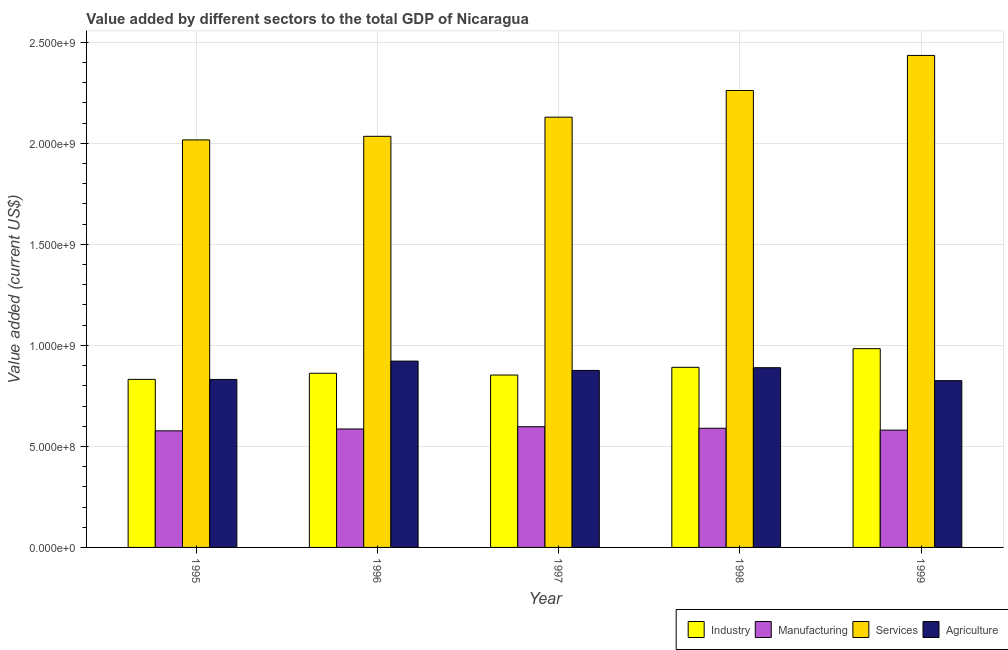Are the number of bars per tick equal to the number of legend labels?
Your answer should be compact. Yes. Are the number of bars on each tick of the X-axis equal?
Your response must be concise. Yes. How many bars are there on the 2nd tick from the left?
Provide a succinct answer. 4. How many bars are there on the 5th tick from the right?
Ensure brevity in your answer.  4. In how many cases, is the number of bars for a given year not equal to the number of legend labels?
Ensure brevity in your answer.  0. What is the value added by industrial sector in 1996?
Provide a short and direct response. 8.62e+08. Across all years, what is the maximum value added by agricultural sector?
Provide a short and direct response. 9.22e+08. Across all years, what is the minimum value added by manufacturing sector?
Provide a short and direct response. 5.77e+08. In which year was the value added by industrial sector maximum?
Offer a very short reply. 1999. In which year was the value added by agricultural sector minimum?
Keep it short and to the point. 1999. What is the total value added by agricultural sector in the graph?
Ensure brevity in your answer.  4.34e+09. What is the difference between the value added by agricultural sector in 1995 and that in 1996?
Provide a succinct answer. -9.08e+07. What is the difference between the value added by industrial sector in 1995 and the value added by manufacturing sector in 1999?
Give a very brief answer. -1.52e+08. What is the average value added by manufacturing sector per year?
Your answer should be very brief. 5.86e+08. In the year 1999, what is the difference between the value added by services sector and value added by agricultural sector?
Offer a very short reply. 0. What is the ratio of the value added by manufacturing sector in 1996 to that in 1998?
Give a very brief answer. 0.99. Is the value added by manufacturing sector in 1997 less than that in 1998?
Keep it short and to the point. No. Is the difference between the value added by services sector in 1995 and 1997 greater than the difference between the value added by manufacturing sector in 1995 and 1997?
Offer a very short reply. No. What is the difference between the highest and the second highest value added by agricultural sector?
Offer a very short reply. 3.27e+07. What is the difference between the highest and the lowest value added by agricultural sector?
Offer a terse response. 9.67e+07. In how many years, is the value added by industrial sector greater than the average value added by industrial sector taken over all years?
Provide a short and direct response. 2. Is the sum of the value added by industrial sector in 1996 and 1998 greater than the maximum value added by agricultural sector across all years?
Your answer should be compact. Yes. Is it the case that in every year, the sum of the value added by industrial sector and value added by agricultural sector is greater than the sum of value added by manufacturing sector and value added by services sector?
Your response must be concise. No. What does the 1st bar from the left in 1998 represents?
Offer a very short reply. Industry. What does the 1st bar from the right in 1996 represents?
Offer a very short reply. Agriculture. Is it the case that in every year, the sum of the value added by industrial sector and value added by manufacturing sector is greater than the value added by services sector?
Offer a terse response. No. How many years are there in the graph?
Provide a succinct answer. 5. Does the graph contain any zero values?
Keep it short and to the point. No. Does the graph contain grids?
Make the answer very short. Yes. Where does the legend appear in the graph?
Provide a succinct answer. Bottom right. How many legend labels are there?
Your answer should be very brief. 4. What is the title of the graph?
Offer a terse response. Value added by different sectors to the total GDP of Nicaragua. What is the label or title of the Y-axis?
Keep it short and to the point. Value added (current US$). What is the Value added (current US$) in Industry in 1995?
Give a very brief answer. 8.32e+08. What is the Value added (current US$) of Manufacturing in 1995?
Your answer should be compact. 5.77e+08. What is the Value added (current US$) in Services in 1995?
Provide a succinct answer. 2.02e+09. What is the Value added (current US$) of Agriculture in 1995?
Give a very brief answer. 8.31e+08. What is the Value added (current US$) of Industry in 1996?
Provide a succinct answer. 8.62e+08. What is the Value added (current US$) in Manufacturing in 1996?
Give a very brief answer. 5.86e+08. What is the Value added (current US$) in Services in 1996?
Offer a terse response. 2.03e+09. What is the Value added (current US$) in Agriculture in 1996?
Your answer should be compact. 9.22e+08. What is the Value added (current US$) of Industry in 1997?
Ensure brevity in your answer.  8.53e+08. What is the Value added (current US$) of Manufacturing in 1997?
Ensure brevity in your answer.  5.98e+08. What is the Value added (current US$) in Services in 1997?
Offer a terse response. 2.13e+09. What is the Value added (current US$) in Agriculture in 1997?
Provide a succinct answer. 8.76e+08. What is the Value added (current US$) of Industry in 1998?
Provide a succinct answer. 8.91e+08. What is the Value added (current US$) in Manufacturing in 1998?
Your answer should be compact. 5.90e+08. What is the Value added (current US$) in Services in 1998?
Your answer should be compact. 2.26e+09. What is the Value added (current US$) in Agriculture in 1998?
Provide a succinct answer. 8.90e+08. What is the Value added (current US$) of Industry in 1999?
Offer a very short reply. 9.84e+08. What is the Value added (current US$) in Manufacturing in 1999?
Your response must be concise. 5.81e+08. What is the Value added (current US$) in Services in 1999?
Make the answer very short. 2.44e+09. What is the Value added (current US$) in Agriculture in 1999?
Your answer should be compact. 8.25e+08. Across all years, what is the maximum Value added (current US$) in Industry?
Keep it short and to the point. 9.84e+08. Across all years, what is the maximum Value added (current US$) of Manufacturing?
Provide a short and direct response. 5.98e+08. Across all years, what is the maximum Value added (current US$) in Services?
Provide a succinct answer. 2.44e+09. Across all years, what is the maximum Value added (current US$) in Agriculture?
Ensure brevity in your answer.  9.22e+08. Across all years, what is the minimum Value added (current US$) in Industry?
Ensure brevity in your answer.  8.32e+08. Across all years, what is the minimum Value added (current US$) in Manufacturing?
Your answer should be compact. 5.77e+08. Across all years, what is the minimum Value added (current US$) in Services?
Make the answer very short. 2.02e+09. Across all years, what is the minimum Value added (current US$) of Agriculture?
Offer a very short reply. 8.25e+08. What is the total Value added (current US$) in Industry in the graph?
Provide a short and direct response. 4.42e+09. What is the total Value added (current US$) of Manufacturing in the graph?
Offer a terse response. 2.93e+09. What is the total Value added (current US$) of Services in the graph?
Offer a very short reply. 1.09e+1. What is the total Value added (current US$) in Agriculture in the graph?
Offer a very short reply. 4.34e+09. What is the difference between the Value added (current US$) of Industry in 1995 and that in 1996?
Keep it short and to the point. -3.02e+07. What is the difference between the Value added (current US$) of Manufacturing in 1995 and that in 1996?
Offer a terse response. -9.22e+06. What is the difference between the Value added (current US$) of Services in 1995 and that in 1996?
Provide a succinct answer. -1.77e+07. What is the difference between the Value added (current US$) of Agriculture in 1995 and that in 1996?
Give a very brief answer. -9.08e+07. What is the difference between the Value added (current US$) in Industry in 1995 and that in 1997?
Provide a short and direct response. -2.14e+07. What is the difference between the Value added (current US$) of Manufacturing in 1995 and that in 1997?
Give a very brief answer. -2.05e+07. What is the difference between the Value added (current US$) of Services in 1995 and that in 1997?
Offer a very short reply. -1.13e+08. What is the difference between the Value added (current US$) of Agriculture in 1995 and that in 1997?
Offer a terse response. -4.47e+07. What is the difference between the Value added (current US$) of Industry in 1995 and that in 1998?
Provide a short and direct response. -5.96e+07. What is the difference between the Value added (current US$) of Manufacturing in 1995 and that in 1998?
Offer a terse response. -1.28e+07. What is the difference between the Value added (current US$) in Services in 1995 and that in 1998?
Ensure brevity in your answer.  -2.45e+08. What is the difference between the Value added (current US$) in Agriculture in 1995 and that in 1998?
Your answer should be compact. -5.81e+07. What is the difference between the Value added (current US$) of Industry in 1995 and that in 1999?
Make the answer very short. -1.52e+08. What is the difference between the Value added (current US$) of Manufacturing in 1995 and that in 1999?
Ensure brevity in your answer.  -3.50e+06. What is the difference between the Value added (current US$) of Services in 1995 and that in 1999?
Ensure brevity in your answer.  -4.18e+08. What is the difference between the Value added (current US$) in Agriculture in 1995 and that in 1999?
Your response must be concise. 5.94e+06. What is the difference between the Value added (current US$) of Industry in 1996 and that in 1997?
Keep it short and to the point. 8.83e+06. What is the difference between the Value added (current US$) in Manufacturing in 1996 and that in 1997?
Ensure brevity in your answer.  -1.13e+07. What is the difference between the Value added (current US$) of Services in 1996 and that in 1997?
Keep it short and to the point. -9.48e+07. What is the difference between the Value added (current US$) in Agriculture in 1996 and that in 1997?
Provide a short and direct response. 4.61e+07. What is the difference between the Value added (current US$) in Industry in 1996 and that in 1998?
Provide a succinct answer. -2.94e+07. What is the difference between the Value added (current US$) in Manufacturing in 1996 and that in 1998?
Your answer should be compact. -3.60e+06. What is the difference between the Value added (current US$) in Services in 1996 and that in 1998?
Make the answer very short. -2.27e+08. What is the difference between the Value added (current US$) in Agriculture in 1996 and that in 1998?
Your answer should be very brief. 3.27e+07. What is the difference between the Value added (current US$) in Industry in 1996 and that in 1999?
Your answer should be very brief. -1.22e+08. What is the difference between the Value added (current US$) in Manufacturing in 1996 and that in 1999?
Offer a very short reply. 5.72e+06. What is the difference between the Value added (current US$) of Services in 1996 and that in 1999?
Offer a very short reply. -4.00e+08. What is the difference between the Value added (current US$) in Agriculture in 1996 and that in 1999?
Offer a terse response. 9.67e+07. What is the difference between the Value added (current US$) of Industry in 1997 and that in 1998?
Offer a very short reply. -3.82e+07. What is the difference between the Value added (current US$) in Manufacturing in 1997 and that in 1998?
Your answer should be compact. 7.65e+06. What is the difference between the Value added (current US$) of Services in 1997 and that in 1998?
Provide a succinct answer. -1.32e+08. What is the difference between the Value added (current US$) in Agriculture in 1997 and that in 1998?
Your answer should be very brief. -1.35e+07. What is the difference between the Value added (current US$) in Industry in 1997 and that in 1999?
Provide a succinct answer. -1.31e+08. What is the difference between the Value added (current US$) of Manufacturing in 1997 and that in 1999?
Keep it short and to the point. 1.70e+07. What is the difference between the Value added (current US$) in Services in 1997 and that in 1999?
Offer a terse response. -3.06e+08. What is the difference between the Value added (current US$) of Agriculture in 1997 and that in 1999?
Provide a succinct answer. 5.06e+07. What is the difference between the Value added (current US$) of Industry in 1998 and that in 1999?
Offer a terse response. -9.23e+07. What is the difference between the Value added (current US$) of Manufacturing in 1998 and that in 1999?
Offer a terse response. 9.32e+06. What is the difference between the Value added (current US$) of Services in 1998 and that in 1999?
Offer a terse response. -1.74e+08. What is the difference between the Value added (current US$) of Agriculture in 1998 and that in 1999?
Your response must be concise. 6.41e+07. What is the difference between the Value added (current US$) in Industry in 1995 and the Value added (current US$) in Manufacturing in 1996?
Your answer should be compact. 2.46e+08. What is the difference between the Value added (current US$) of Industry in 1995 and the Value added (current US$) of Services in 1996?
Ensure brevity in your answer.  -1.20e+09. What is the difference between the Value added (current US$) in Industry in 1995 and the Value added (current US$) in Agriculture in 1996?
Provide a short and direct response. -9.04e+07. What is the difference between the Value added (current US$) in Manufacturing in 1995 and the Value added (current US$) in Services in 1996?
Your answer should be compact. -1.46e+09. What is the difference between the Value added (current US$) of Manufacturing in 1995 and the Value added (current US$) of Agriculture in 1996?
Your answer should be very brief. -3.45e+08. What is the difference between the Value added (current US$) in Services in 1995 and the Value added (current US$) in Agriculture in 1996?
Give a very brief answer. 1.09e+09. What is the difference between the Value added (current US$) in Industry in 1995 and the Value added (current US$) in Manufacturing in 1997?
Provide a succinct answer. 2.34e+08. What is the difference between the Value added (current US$) of Industry in 1995 and the Value added (current US$) of Services in 1997?
Your answer should be compact. -1.30e+09. What is the difference between the Value added (current US$) of Industry in 1995 and the Value added (current US$) of Agriculture in 1997?
Provide a succinct answer. -4.43e+07. What is the difference between the Value added (current US$) in Manufacturing in 1995 and the Value added (current US$) in Services in 1997?
Your response must be concise. -1.55e+09. What is the difference between the Value added (current US$) in Manufacturing in 1995 and the Value added (current US$) in Agriculture in 1997?
Keep it short and to the point. -2.99e+08. What is the difference between the Value added (current US$) in Services in 1995 and the Value added (current US$) in Agriculture in 1997?
Your answer should be compact. 1.14e+09. What is the difference between the Value added (current US$) of Industry in 1995 and the Value added (current US$) of Manufacturing in 1998?
Your answer should be very brief. 2.42e+08. What is the difference between the Value added (current US$) of Industry in 1995 and the Value added (current US$) of Services in 1998?
Your answer should be compact. -1.43e+09. What is the difference between the Value added (current US$) of Industry in 1995 and the Value added (current US$) of Agriculture in 1998?
Provide a short and direct response. -5.77e+07. What is the difference between the Value added (current US$) of Manufacturing in 1995 and the Value added (current US$) of Services in 1998?
Give a very brief answer. -1.68e+09. What is the difference between the Value added (current US$) of Manufacturing in 1995 and the Value added (current US$) of Agriculture in 1998?
Provide a short and direct response. -3.12e+08. What is the difference between the Value added (current US$) in Services in 1995 and the Value added (current US$) in Agriculture in 1998?
Offer a very short reply. 1.13e+09. What is the difference between the Value added (current US$) in Industry in 1995 and the Value added (current US$) in Manufacturing in 1999?
Your response must be concise. 2.51e+08. What is the difference between the Value added (current US$) in Industry in 1995 and the Value added (current US$) in Services in 1999?
Provide a succinct answer. -1.60e+09. What is the difference between the Value added (current US$) in Industry in 1995 and the Value added (current US$) in Agriculture in 1999?
Offer a terse response. 6.36e+06. What is the difference between the Value added (current US$) of Manufacturing in 1995 and the Value added (current US$) of Services in 1999?
Ensure brevity in your answer.  -1.86e+09. What is the difference between the Value added (current US$) in Manufacturing in 1995 and the Value added (current US$) in Agriculture in 1999?
Your answer should be very brief. -2.48e+08. What is the difference between the Value added (current US$) in Services in 1995 and the Value added (current US$) in Agriculture in 1999?
Provide a short and direct response. 1.19e+09. What is the difference between the Value added (current US$) in Industry in 1996 and the Value added (current US$) in Manufacturing in 1997?
Provide a succinct answer. 2.65e+08. What is the difference between the Value added (current US$) in Industry in 1996 and the Value added (current US$) in Services in 1997?
Offer a terse response. -1.27e+09. What is the difference between the Value added (current US$) of Industry in 1996 and the Value added (current US$) of Agriculture in 1997?
Keep it short and to the point. -1.40e+07. What is the difference between the Value added (current US$) of Manufacturing in 1996 and the Value added (current US$) of Services in 1997?
Offer a terse response. -1.54e+09. What is the difference between the Value added (current US$) in Manufacturing in 1996 and the Value added (current US$) in Agriculture in 1997?
Ensure brevity in your answer.  -2.90e+08. What is the difference between the Value added (current US$) of Services in 1996 and the Value added (current US$) of Agriculture in 1997?
Offer a terse response. 1.16e+09. What is the difference between the Value added (current US$) of Industry in 1996 and the Value added (current US$) of Manufacturing in 1998?
Your answer should be very brief. 2.72e+08. What is the difference between the Value added (current US$) in Industry in 1996 and the Value added (current US$) in Services in 1998?
Make the answer very short. -1.40e+09. What is the difference between the Value added (current US$) of Industry in 1996 and the Value added (current US$) of Agriculture in 1998?
Provide a short and direct response. -2.75e+07. What is the difference between the Value added (current US$) of Manufacturing in 1996 and the Value added (current US$) of Services in 1998?
Your response must be concise. -1.68e+09. What is the difference between the Value added (current US$) in Manufacturing in 1996 and the Value added (current US$) in Agriculture in 1998?
Offer a very short reply. -3.03e+08. What is the difference between the Value added (current US$) in Services in 1996 and the Value added (current US$) in Agriculture in 1998?
Provide a short and direct response. 1.15e+09. What is the difference between the Value added (current US$) in Industry in 1996 and the Value added (current US$) in Manufacturing in 1999?
Give a very brief answer. 2.82e+08. What is the difference between the Value added (current US$) in Industry in 1996 and the Value added (current US$) in Services in 1999?
Make the answer very short. -1.57e+09. What is the difference between the Value added (current US$) in Industry in 1996 and the Value added (current US$) in Agriculture in 1999?
Provide a succinct answer. 3.66e+07. What is the difference between the Value added (current US$) in Manufacturing in 1996 and the Value added (current US$) in Services in 1999?
Make the answer very short. -1.85e+09. What is the difference between the Value added (current US$) in Manufacturing in 1996 and the Value added (current US$) in Agriculture in 1999?
Your response must be concise. -2.39e+08. What is the difference between the Value added (current US$) of Services in 1996 and the Value added (current US$) of Agriculture in 1999?
Provide a short and direct response. 1.21e+09. What is the difference between the Value added (current US$) of Industry in 1997 and the Value added (current US$) of Manufacturing in 1998?
Offer a terse response. 2.63e+08. What is the difference between the Value added (current US$) of Industry in 1997 and the Value added (current US$) of Services in 1998?
Your response must be concise. -1.41e+09. What is the difference between the Value added (current US$) in Industry in 1997 and the Value added (current US$) in Agriculture in 1998?
Provide a short and direct response. -3.63e+07. What is the difference between the Value added (current US$) in Manufacturing in 1997 and the Value added (current US$) in Services in 1998?
Give a very brief answer. -1.66e+09. What is the difference between the Value added (current US$) of Manufacturing in 1997 and the Value added (current US$) of Agriculture in 1998?
Offer a terse response. -2.92e+08. What is the difference between the Value added (current US$) of Services in 1997 and the Value added (current US$) of Agriculture in 1998?
Offer a very short reply. 1.24e+09. What is the difference between the Value added (current US$) of Industry in 1997 and the Value added (current US$) of Manufacturing in 1999?
Your response must be concise. 2.73e+08. What is the difference between the Value added (current US$) in Industry in 1997 and the Value added (current US$) in Services in 1999?
Keep it short and to the point. -1.58e+09. What is the difference between the Value added (current US$) of Industry in 1997 and the Value added (current US$) of Agriculture in 1999?
Your answer should be very brief. 2.78e+07. What is the difference between the Value added (current US$) in Manufacturing in 1997 and the Value added (current US$) in Services in 1999?
Your answer should be compact. -1.84e+09. What is the difference between the Value added (current US$) in Manufacturing in 1997 and the Value added (current US$) in Agriculture in 1999?
Offer a very short reply. -2.28e+08. What is the difference between the Value added (current US$) in Services in 1997 and the Value added (current US$) in Agriculture in 1999?
Ensure brevity in your answer.  1.30e+09. What is the difference between the Value added (current US$) in Industry in 1998 and the Value added (current US$) in Manufacturing in 1999?
Offer a terse response. 3.11e+08. What is the difference between the Value added (current US$) in Industry in 1998 and the Value added (current US$) in Services in 1999?
Give a very brief answer. -1.54e+09. What is the difference between the Value added (current US$) in Industry in 1998 and the Value added (current US$) in Agriculture in 1999?
Offer a terse response. 6.60e+07. What is the difference between the Value added (current US$) in Manufacturing in 1998 and the Value added (current US$) in Services in 1999?
Your response must be concise. -1.85e+09. What is the difference between the Value added (current US$) in Manufacturing in 1998 and the Value added (current US$) in Agriculture in 1999?
Provide a short and direct response. -2.36e+08. What is the difference between the Value added (current US$) in Services in 1998 and the Value added (current US$) in Agriculture in 1999?
Provide a short and direct response. 1.44e+09. What is the average Value added (current US$) in Industry per year?
Provide a short and direct response. 8.84e+08. What is the average Value added (current US$) in Manufacturing per year?
Provide a succinct answer. 5.86e+08. What is the average Value added (current US$) in Services per year?
Keep it short and to the point. 2.18e+09. What is the average Value added (current US$) of Agriculture per year?
Keep it short and to the point. 8.69e+08. In the year 1995, what is the difference between the Value added (current US$) of Industry and Value added (current US$) of Manufacturing?
Provide a short and direct response. 2.55e+08. In the year 1995, what is the difference between the Value added (current US$) in Industry and Value added (current US$) in Services?
Your answer should be compact. -1.19e+09. In the year 1995, what is the difference between the Value added (current US$) in Industry and Value added (current US$) in Agriculture?
Give a very brief answer. 4.19e+05. In the year 1995, what is the difference between the Value added (current US$) of Manufacturing and Value added (current US$) of Services?
Your answer should be compact. -1.44e+09. In the year 1995, what is the difference between the Value added (current US$) in Manufacturing and Value added (current US$) in Agriculture?
Your answer should be very brief. -2.54e+08. In the year 1995, what is the difference between the Value added (current US$) in Services and Value added (current US$) in Agriculture?
Your answer should be compact. 1.19e+09. In the year 1996, what is the difference between the Value added (current US$) of Industry and Value added (current US$) of Manufacturing?
Offer a terse response. 2.76e+08. In the year 1996, what is the difference between the Value added (current US$) of Industry and Value added (current US$) of Services?
Provide a short and direct response. -1.17e+09. In the year 1996, what is the difference between the Value added (current US$) in Industry and Value added (current US$) in Agriculture?
Your response must be concise. -6.01e+07. In the year 1996, what is the difference between the Value added (current US$) of Manufacturing and Value added (current US$) of Services?
Give a very brief answer. -1.45e+09. In the year 1996, what is the difference between the Value added (current US$) of Manufacturing and Value added (current US$) of Agriculture?
Your response must be concise. -3.36e+08. In the year 1996, what is the difference between the Value added (current US$) in Services and Value added (current US$) in Agriculture?
Keep it short and to the point. 1.11e+09. In the year 1997, what is the difference between the Value added (current US$) of Industry and Value added (current US$) of Manufacturing?
Ensure brevity in your answer.  2.56e+08. In the year 1997, what is the difference between the Value added (current US$) of Industry and Value added (current US$) of Services?
Offer a terse response. -1.28e+09. In the year 1997, what is the difference between the Value added (current US$) of Industry and Value added (current US$) of Agriculture?
Make the answer very short. -2.28e+07. In the year 1997, what is the difference between the Value added (current US$) of Manufacturing and Value added (current US$) of Services?
Provide a short and direct response. -1.53e+09. In the year 1997, what is the difference between the Value added (current US$) of Manufacturing and Value added (current US$) of Agriculture?
Your response must be concise. -2.79e+08. In the year 1997, what is the difference between the Value added (current US$) of Services and Value added (current US$) of Agriculture?
Provide a short and direct response. 1.25e+09. In the year 1998, what is the difference between the Value added (current US$) of Industry and Value added (current US$) of Manufacturing?
Make the answer very short. 3.02e+08. In the year 1998, what is the difference between the Value added (current US$) in Industry and Value added (current US$) in Services?
Ensure brevity in your answer.  -1.37e+09. In the year 1998, what is the difference between the Value added (current US$) in Industry and Value added (current US$) in Agriculture?
Ensure brevity in your answer.  1.93e+06. In the year 1998, what is the difference between the Value added (current US$) of Manufacturing and Value added (current US$) of Services?
Your answer should be very brief. -1.67e+09. In the year 1998, what is the difference between the Value added (current US$) in Manufacturing and Value added (current US$) in Agriculture?
Provide a short and direct response. -3.00e+08. In the year 1998, what is the difference between the Value added (current US$) in Services and Value added (current US$) in Agriculture?
Provide a short and direct response. 1.37e+09. In the year 1999, what is the difference between the Value added (current US$) in Industry and Value added (current US$) in Manufacturing?
Keep it short and to the point. 4.03e+08. In the year 1999, what is the difference between the Value added (current US$) of Industry and Value added (current US$) of Services?
Your answer should be compact. -1.45e+09. In the year 1999, what is the difference between the Value added (current US$) of Industry and Value added (current US$) of Agriculture?
Your response must be concise. 1.58e+08. In the year 1999, what is the difference between the Value added (current US$) of Manufacturing and Value added (current US$) of Services?
Offer a very short reply. -1.85e+09. In the year 1999, what is the difference between the Value added (current US$) in Manufacturing and Value added (current US$) in Agriculture?
Your response must be concise. -2.45e+08. In the year 1999, what is the difference between the Value added (current US$) in Services and Value added (current US$) in Agriculture?
Offer a terse response. 1.61e+09. What is the ratio of the Value added (current US$) of Industry in 1995 to that in 1996?
Make the answer very short. 0.96. What is the ratio of the Value added (current US$) of Manufacturing in 1995 to that in 1996?
Ensure brevity in your answer.  0.98. What is the ratio of the Value added (current US$) in Services in 1995 to that in 1996?
Ensure brevity in your answer.  0.99. What is the ratio of the Value added (current US$) in Agriculture in 1995 to that in 1996?
Your answer should be compact. 0.9. What is the ratio of the Value added (current US$) in Industry in 1995 to that in 1997?
Make the answer very short. 0.97. What is the ratio of the Value added (current US$) in Manufacturing in 1995 to that in 1997?
Ensure brevity in your answer.  0.97. What is the ratio of the Value added (current US$) of Services in 1995 to that in 1997?
Your answer should be compact. 0.95. What is the ratio of the Value added (current US$) of Agriculture in 1995 to that in 1997?
Provide a succinct answer. 0.95. What is the ratio of the Value added (current US$) in Industry in 1995 to that in 1998?
Offer a terse response. 0.93. What is the ratio of the Value added (current US$) in Manufacturing in 1995 to that in 1998?
Keep it short and to the point. 0.98. What is the ratio of the Value added (current US$) of Services in 1995 to that in 1998?
Your answer should be very brief. 0.89. What is the ratio of the Value added (current US$) in Agriculture in 1995 to that in 1998?
Ensure brevity in your answer.  0.93. What is the ratio of the Value added (current US$) in Industry in 1995 to that in 1999?
Give a very brief answer. 0.85. What is the ratio of the Value added (current US$) in Manufacturing in 1995 to that in 1999?
Your answer should be very brief. 0.99. What is the ratio of the Value added (current US$) of Services in 1995 to that in 1999?
Offer a terse response. 0.83. What is the ratio of the Value added (current US$) of Agriculture in 1995 to that in 1999?
Ensure brevity in your answer.  1.01. What is the ratio of the Value added (current US$) in Industry in 1996 to that in 1997?
Your response must be concise. 1.01. What is the ratio of the Value added (current US$) of Manufacturing in 1996 to that in 1997?
Keep it short and to the point. 0.98. What is the ratio of the Value added (current US$) of Services in 1996 to that in 1997?
Offer a very short reply. 0.96. What is the ratio of the Value added (current US$) of Agriculture in 1996 to that in 1997?
Your answer should be very brief. 1.05. What is the ratio of the Value added (current US$) of Services in 1996 to that in 1998?
Your answer should be very brief. 0.9. What is the ratio of the Value added (current US$) of Agriculture in 1996 to that in 1998?
Your answer should be very brief. 1.04. What is the ratio of the Value added (current US$) in Industry in 1996 to that in 1999?
Offer a terse response. 0.88. What is the ratio of the Value added (current US$) in Manufacturing in 1996 to that in 1999?
Your response must be concise. 1.01. What is the ratio of the Value added (current US$) of Services in 1996 to that in 1999?
Provide a succinct answer. 0.84. What is the ratio of the Value added (current US$) of Agriculture in 1996 to that in 1999?
Your answer should be very brief. 1.12. What is the ratio of the Value added (current US$) in Industry in 1997 to that in 1998?
Ensure brevity in your answer.  0.96. What is the ratio of the Value added (current US$) in Services in 1997 to that in 1998?
Offer a terse response. 0.94. What is the ratio of the Value added (current US$) in Agriculture in 1997 to that in 1998?
Offer a terse response. 0.98. What is the ratio of the Value added (current US$) in Industry in 1997 to that in 1999?
Ensure brevity in your answer.  0.87. What is the ratio of the Value added (current US$) of Manufacturing in 1997 to that in 1999?
Provide a short and direct response. 1.03. What is the ratio of the Value added (current US$) of Services in 1997 to that in 1999?
Offer a very short reply. 0.87. What is the ratio of the Value added (current US$) in Agriculture in 1997 to that in 1999?
Your answer should be very brief. 1.06. What is the ratio of the Value added (current US$) in Industry in 1998 to that in 1999?
Your answer should be compact. 0.91. What is the ratio of the Value added (current US$) in Manufacturing in 1998 to that in 1999?
Your answer should be compact. 1.02. What is the ratio of the Value added (current US$) of Services in 1998 to that in 1999?
Provide a short and direct response. 0.93. What is the ratio of the Value added (current US$) of Agriculture in 1998 to that in 1999?
Ensure brevity in your answer.  1.08. What is the difference between the highest and the second highest Value added (current US$) of Industry?
Your response must be concise. 9.23e+07. What is the difference between the highest and the second highest Value added (current US$) of Manufacturing?
Keep it short and to the point. 7.65e+06. What is the difference between the highest and the second highest Value added (current US$) in Services?
Give a very brief answer. 1.74e+08. What is the difference between the highest and the second highest Value added (current US$) in Agriculture?
Offer a terse response. 3.27e+07. What is the difference between the highest and the lowest Value added (current US$) of Industry?
Give a very brief answer. 1.52e+08. What is the difference between the highest and the lowest Value added (current US$) in Manufacturing?
Offer a very short reply. 2.05e+07. What is the difference between the highest and the lowest Value added (current US$) of Services?
Provide a succinct answer. 4.18e+08. What is the difference between the highest and the lowest Value added (current US$) in Agriculture?
Provide a short and direct response. 9.67e+07. 